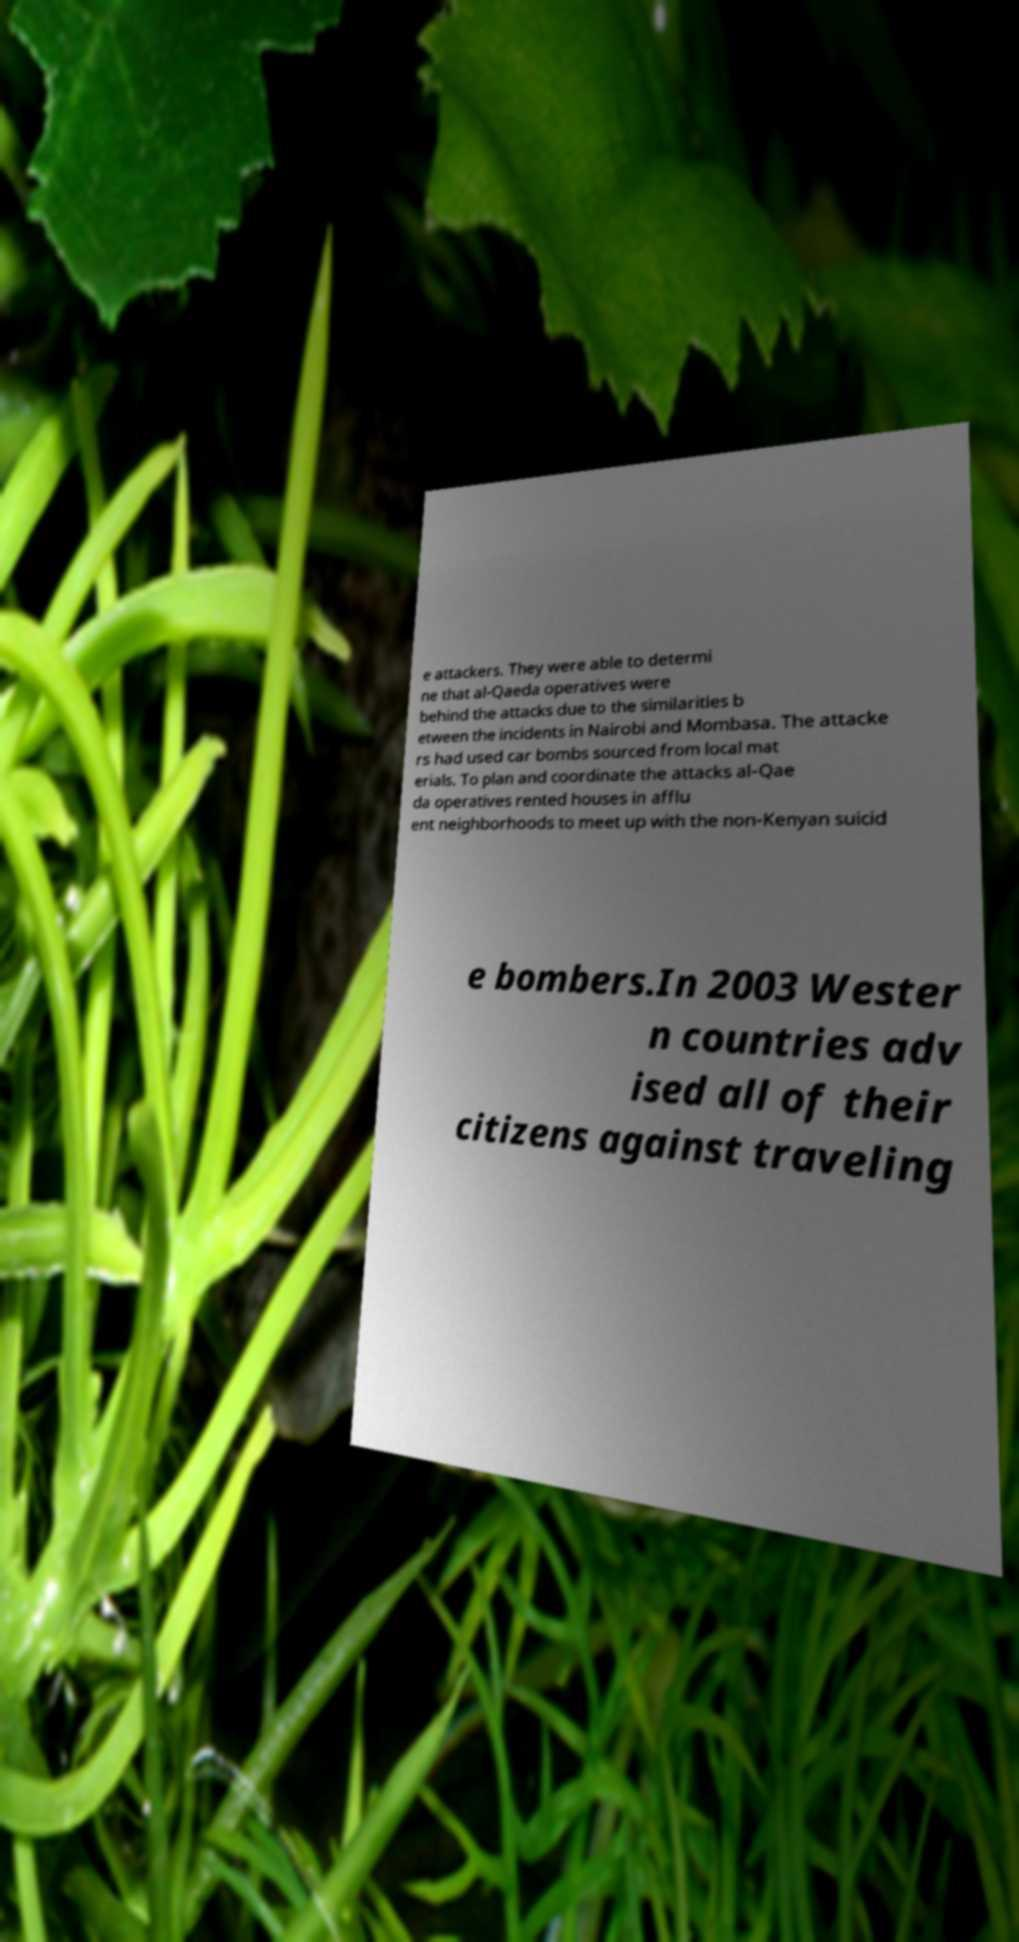Please identify and transcribe the text found in this image. e attackers. They were able to determi ne that al-Qaeda operatives were behind the attacks due to the similarities b etween the incidents in Nairobi and Mombasa. The attacke rs had used car bombs sourced from local mat erials. To plan and coordinate the attacks al-Qae da operatives rented houses in afflu ent neighborhoods to meet up with the non-Kenyan suicid e bombers.In 2003 Wester n countries adv ised all of their citizens against traveling 